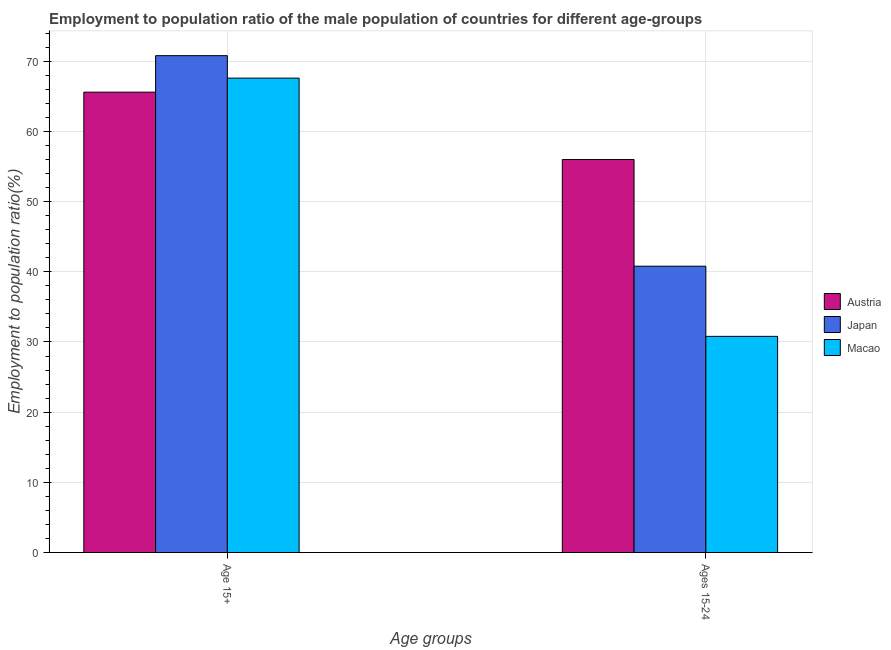How many different coloured bars are there?
Your answer should be compact. 3. How many groups of bars are there?
Offer a terse response. 2. Are the number of bars per tick equal to the number of legend labels?
Give a very brief answer. Yes. Are the number of bars on each tick of the X-axis equal?
Provide a short and direct response. Yes. How many bars are there on the 2nd tick from the left?
Give a very brief answer. 3. What is the label of the 1st group of bars from the left?
Give a very brief answer. Age 15+. What is the employment to population ratio(age 15+) in Japan?
Make the answer very short. 70.8. Across all countries, what is the maximum employment to population ratio(age 15+)?
Your answer should be very brief. 70.8. Across all countries, what is the minimum employment to population ratio(age 15-24)?
Offer a terse response. 30.8. In which country was the employment to population ratio(age 15+) maximum?
Make the answer very short. Japan. In which country was the employment to population ratio(age 15-24) minimum?
Provide a succinct answer. Macao. What is the total employment to population ratio(age 15+) in the graph?
Your answer should be very brief. 204. What is the difference between the employment to population ratio(age 15-24) in Austria and that in Macao?
Provide a succinct answer. 25.2. What is the difference between the employment to population ratio(age 15+) in Austria and the employment to population ratio(age 15-24) in Macao?
Ensure brevity in your answer.  34.8. What is the average employment to population ratio(age 15+) per country?
Offer a terse response. 68. What is the difference between the employment to population ratio(age 15-24) and employment to population ratio(age 15+) in Macao?
Give a very brief answer. -36.8. In how many countries, is the employment to population ratio(age 15-24) greater than 16 %?
Provide a short and direct response. 3. What is the ratio of the employment to population ratio(age 15-24) in Japan to that in Austria?
Give a very brief answer. 0.73. What does the 1st bar from the left in Age 15+ represents?
Your answer should be compact. Austria. What does the 1st bar from the right in Age 15+ represents?
Offer a very short reply. Macao. How many bars are there?
Offer a very short reply. 6. Are all the bars in the graph horizontal?
Ensure brevity in your answer.  No. How many countries are there in the graph?
Ensure brevity in your answer.  3. Are the values on the major ticks of Y-axis written in scientific E-notation?
Provide a succinct answer. No. What is the title of the graph?
Provide a short and direct response. Employment to population ratio of the male population of countries for different age-groups. What is the label or title of the X-axis?
Offer a very short reply. Age groups. What is the label or title of the Y-axis?
Your response must be concise. Employment to population ratio(%). What is the Employment to population ratio(%) of Austria in Age 15+?
Provide a short and direct response. 65.6. What is the Employment to population ratio(%) of Japan in Age 15+?
Your answer should be compact. 70.8. What is the Employment to population ratio(%) in Macao in Age 15+?
Provide a succinct answer. 67.6. What is the Employment to population ratio(%) in Austria in Ages 15-24?
Your answer should be compact. 56. What is the Employment to population ratio(%) of Japan in Ages 15-24?
Your response must be concise. 40.8. What is the Employment to population ratio(%) of Macao in Ages 15-24?
Your response must be concise. 30.8. Across all Age groups, what is the maximum Employment to population ratio(%) in Austria?
Offer a terse response. 65.6. Across all Age groups, what is the maximum Employment to population ratio(%) of Japan?
Give a very brief answer. 70.8. Across all Age groups, what is the maximum Employment to population ratio(%) of Macao?
Ensure brevity in your answer.  67.6. Across all Age groups, what is the minimum Employment to population ratio(%) of Austria?
Keep it short and to the point. 56. Across all Age groups, what is the minimum Employment to population ratio(%) of Japan?
Offer a terse response. 40.8. Across all Age groups, what is the minimum Employment to population ratio(%) in Macao?
Provide a succinct answer. 30.8. What is the total Employment to population ratio(%) of Austria in the graph?
Your response must be concise. 121.6. What is the total Employment to population ratio(%) of Japan in the graph?
Keep it short and to the point. 111.6. What is the total Employment to population ratio(%) in Macao in the graph?
Offer a very short reply. 98.4. What is the difference between the Employment to population ratio(%) of Austria in Age 15+ and that in Ages 15-24?
Your answer should be compact. 9.6. What is the difference between the Employment to population ratio(%) in Japan in Age 15+ and that in Ages 15-24?
Offer a very short reply. 30. What is the difference between the Employment to population ratio(%) in Macao in Age 15+ and that in Ages 15-24?
Your answer should be compact. 36.8. What is the difference between the Employment to population ratio(%) in Austria in Age 15+ and the Employment to population ratio(%) in Japan in Ages 15-24?
Offer a very short reply. 24.8. What is the difference between the Employment to population ratio(%) of Austria in Age 15+ and the Employment to population ratio(%) of Macao in Ages 15-24?
Provide a short and direct response. 34.8. What is the average Employment to population ratio(%) in Austria per Age groups?
Give a very brief answer. 60.8. What is the average Employment to population ratio(%) in Japan per Age groups?
Give a very brief answer. 55.8. What is the average Employment to population ratio(%) of Macao per Age groups?
Your answer should be very brief. 49.2. What is the difference between the Employment to population ratio(%) of Japan and Employment to population ratio(%) of Macao in Age 15+?
Make the answer very short. 3.2. What is the difference between the Employment to population ratio(%) in Austria and Employment to population ratio(%) in Macao in Ages 15-24?
Make the answer very short. 25.2. What is the difference between the Employment to population ratio(%) of Japan and Employment to population ratio(%) of Macao in Ages 15-24?
Offer a very short reply. 10. What is the ratio of the Employment to population ratio(%) in Austria in Age 15+ to that in Ages 15-24?
Your answer should be compact. 1.17. What is the ratio of the Employment to population ratio(%) in Japan in Age 15+ to that in Ages 15-24?
Offer a very short reply. 1.74. What is the ratio of the Employment to population ratio(%) in Macao in Age 15+ to that in Ages 15-24?
Provide a short and direct response. 2.19. What is the difference between the highest and the second highest Employment to population ratio(%) in Austria?
Your answer should be compact. 9.6. What is the difference between the highest and the second highest Employment to population ratio(%) in Macao?
Your answer should be compact. 36.8. What is the difference between the highest and the lowest Employment to population ratio(%) in Japan?
Provide a succinct answer. 30. What is the difference between the highest and the lowest Employment to population ratio(%) in Macao?
Your answer should be very brief. 36.8. 